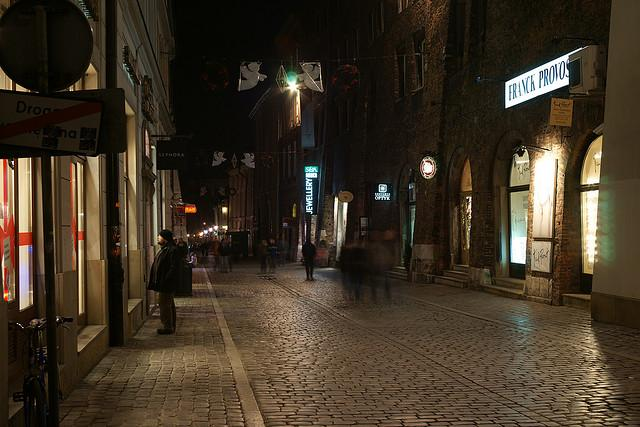What zone is depicted in the photo?

Choices:
A) residential
B) traffic
C) business
D) shopping shopping 